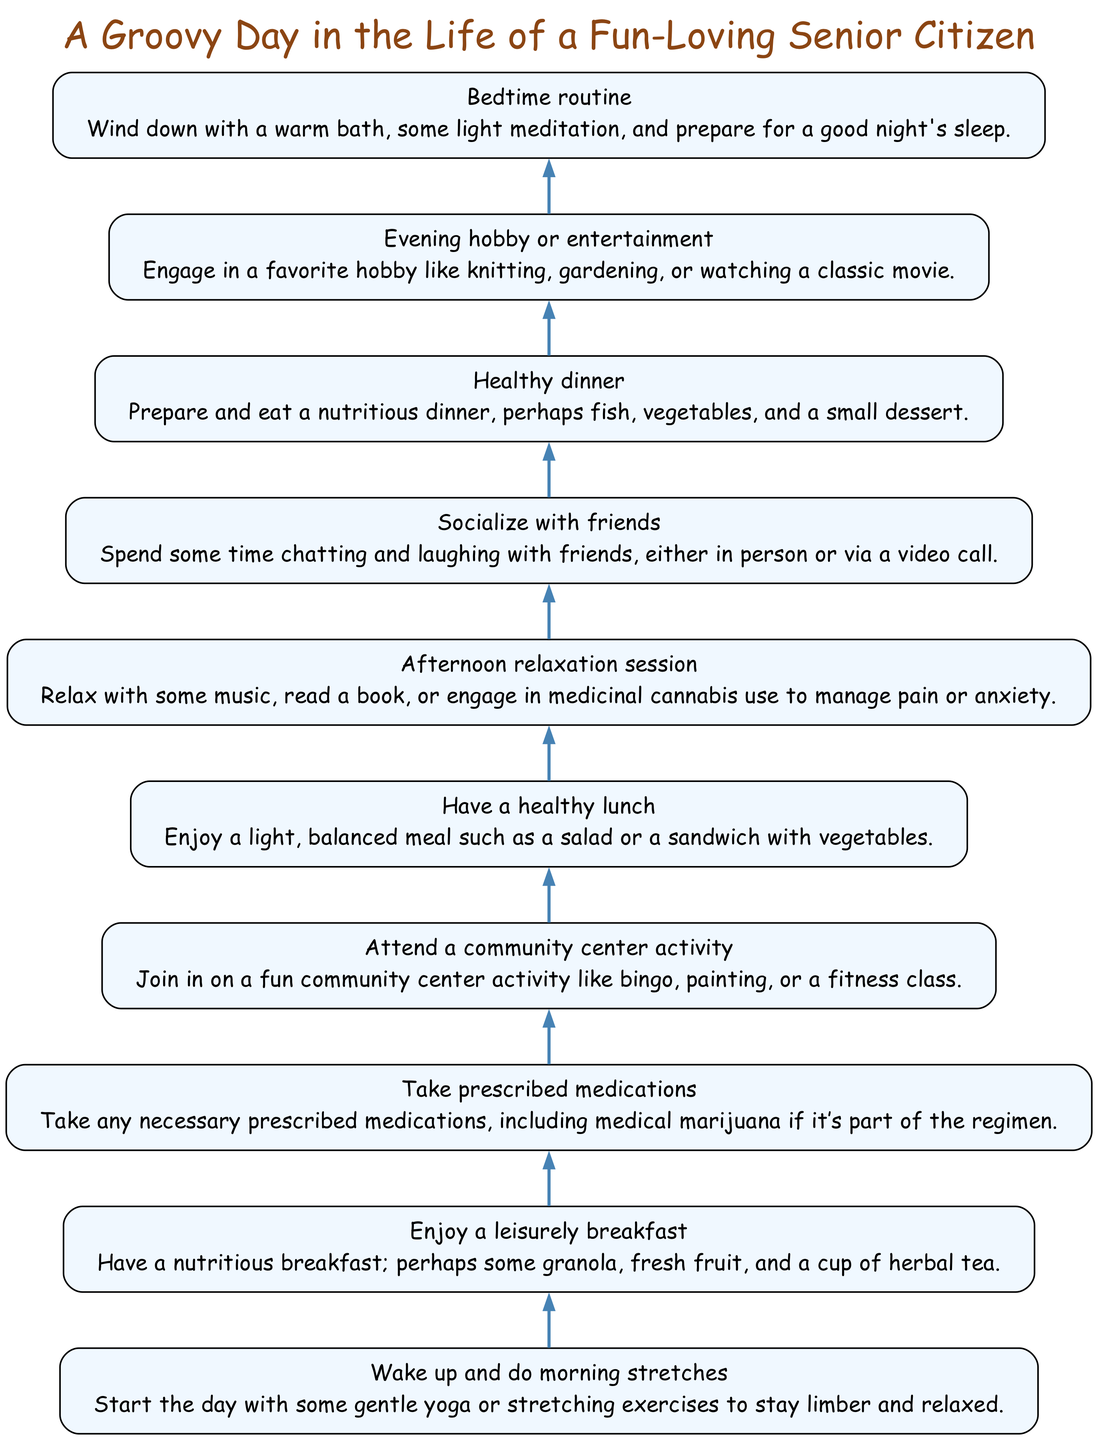What is the first activity shown in the diagram? The diagram starts with "Wake up and do morning stretches" as the first activity at the bottom. This is the first node listed in the flow chart.
Answer: Wake up and do morning stretches How many total activities are there in the diagram? The diagram lists 10 activities from top to bottom. Counting each element labeled in the flow chart leads to this total.
Answer: 10 What follows 'Take prescribed medications' in the flow chart? The flow arrow leads from 'Take prescribed medications' to 'Attend a community center activity', indicating the next activity in sequence.
Answer: Attend a community center activity Which activity occurs just before 'Healthy dinner'? 'Socialize with friends' is directly before 'Healthy dinner' in the sequence, making it the activity that comes right before it.
Answer: Socialize with friends What is the common theme of the activities in the flow chart? The activities revolve around maintaining a healthy, enjoyable lifestyle as a senior citizen, emphasizing wellness and enjoyment.
Answer: Wellness and enjoyment How many meals are indicated in the daily schedule? The diagram includes three meals: breakfast, lunch, and dinner, as shown individually in the chart.
Answer: 3 Which activity involves leisure and social interaction? 'Socialize with friends' involves both leisure and social interaction, reflecting enjoyment with companionship in the diagram.
Answer: Socialize with friends What does the last node in the chart represent? The last node is 'Bedtime routine', indicating the final activity before ending the day, thus representing closure to the daily routine.
Answer: Bedtime routine What is the main purpose of the 'Afternoon relaxation session'? It aims to provide relaxation and stress relief, incorporating activities like listening to music or possibly using medicinal cannabis, as mentioned.
Answer: Relaxation and stress relief Which activity includes a specific reference to medicinal marijuana? 'Take prescribed medications' has a direct reference to including medical marijuana as part of the essential regimen for health management in the flow.
Answer: Take prescribed medications 